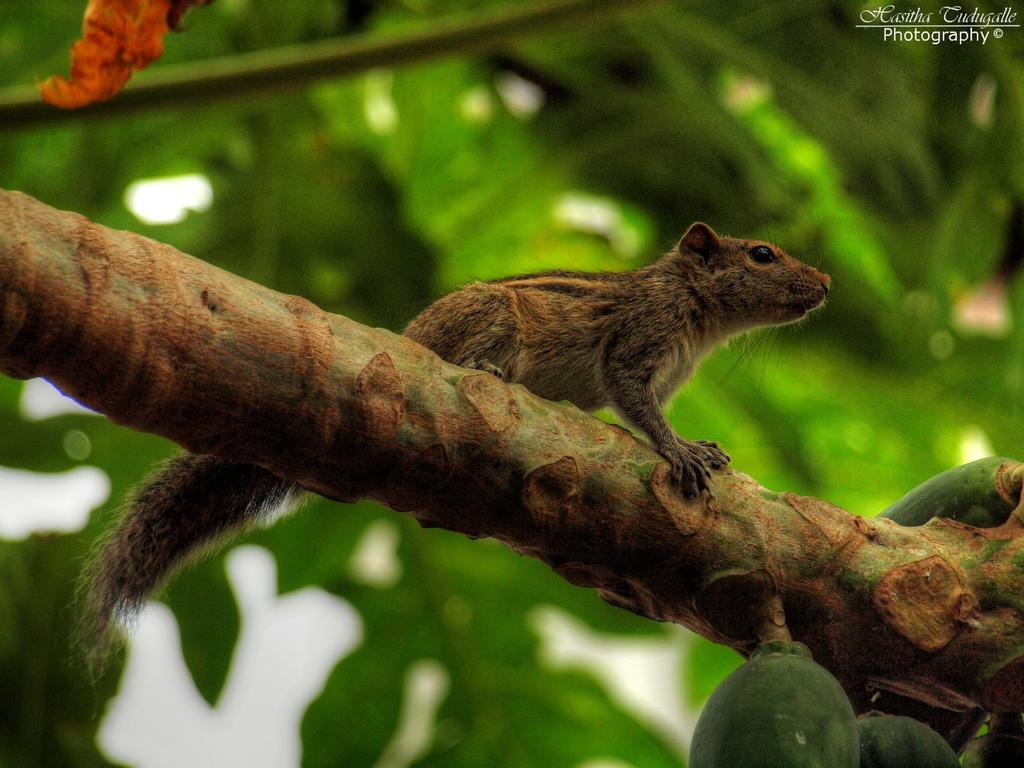What animal is present in the image? There is a squirrel in the image. Where is the squirrel located? The squirrel is on a stem. What else can be seen on the stem? There are fruits on the stem. What can be seen in the background of the image? The background of the image includes leaves. How does the squirrel draw attention to its shiny polish in the image? The squirrel does not have any polish in the image, and there is no indication that it is trying to draw attention to anything. 